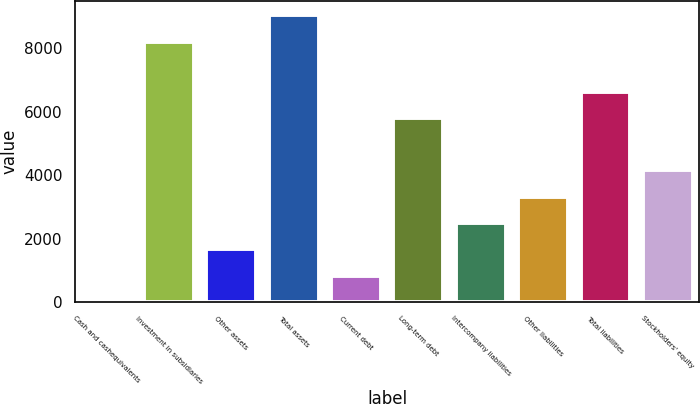Convert chart to OTSL. <chart><loc_0><loc_0><loc_500><loc_500><bar_chart><fcel>Cash and cashequivalents<fcel>Investment in subsidiaries<fcel>Other assets<fcel>Total assets<fcel>Current debt<fcel>Long-term debt<fcel>Intercompany liabilities<fcel>Other liabilities<fcel>Total liabilities<fcel>Stockholders' equity<nl><fcel>0.1<fcel>8203.9<fcel>1659.94<fcel>9033.82<fcel>830.02<fcel>5797.5<fcel>2489.86<fcel>3319.78<fcel>6627.42<fcel>4149.7<nl></chart> 